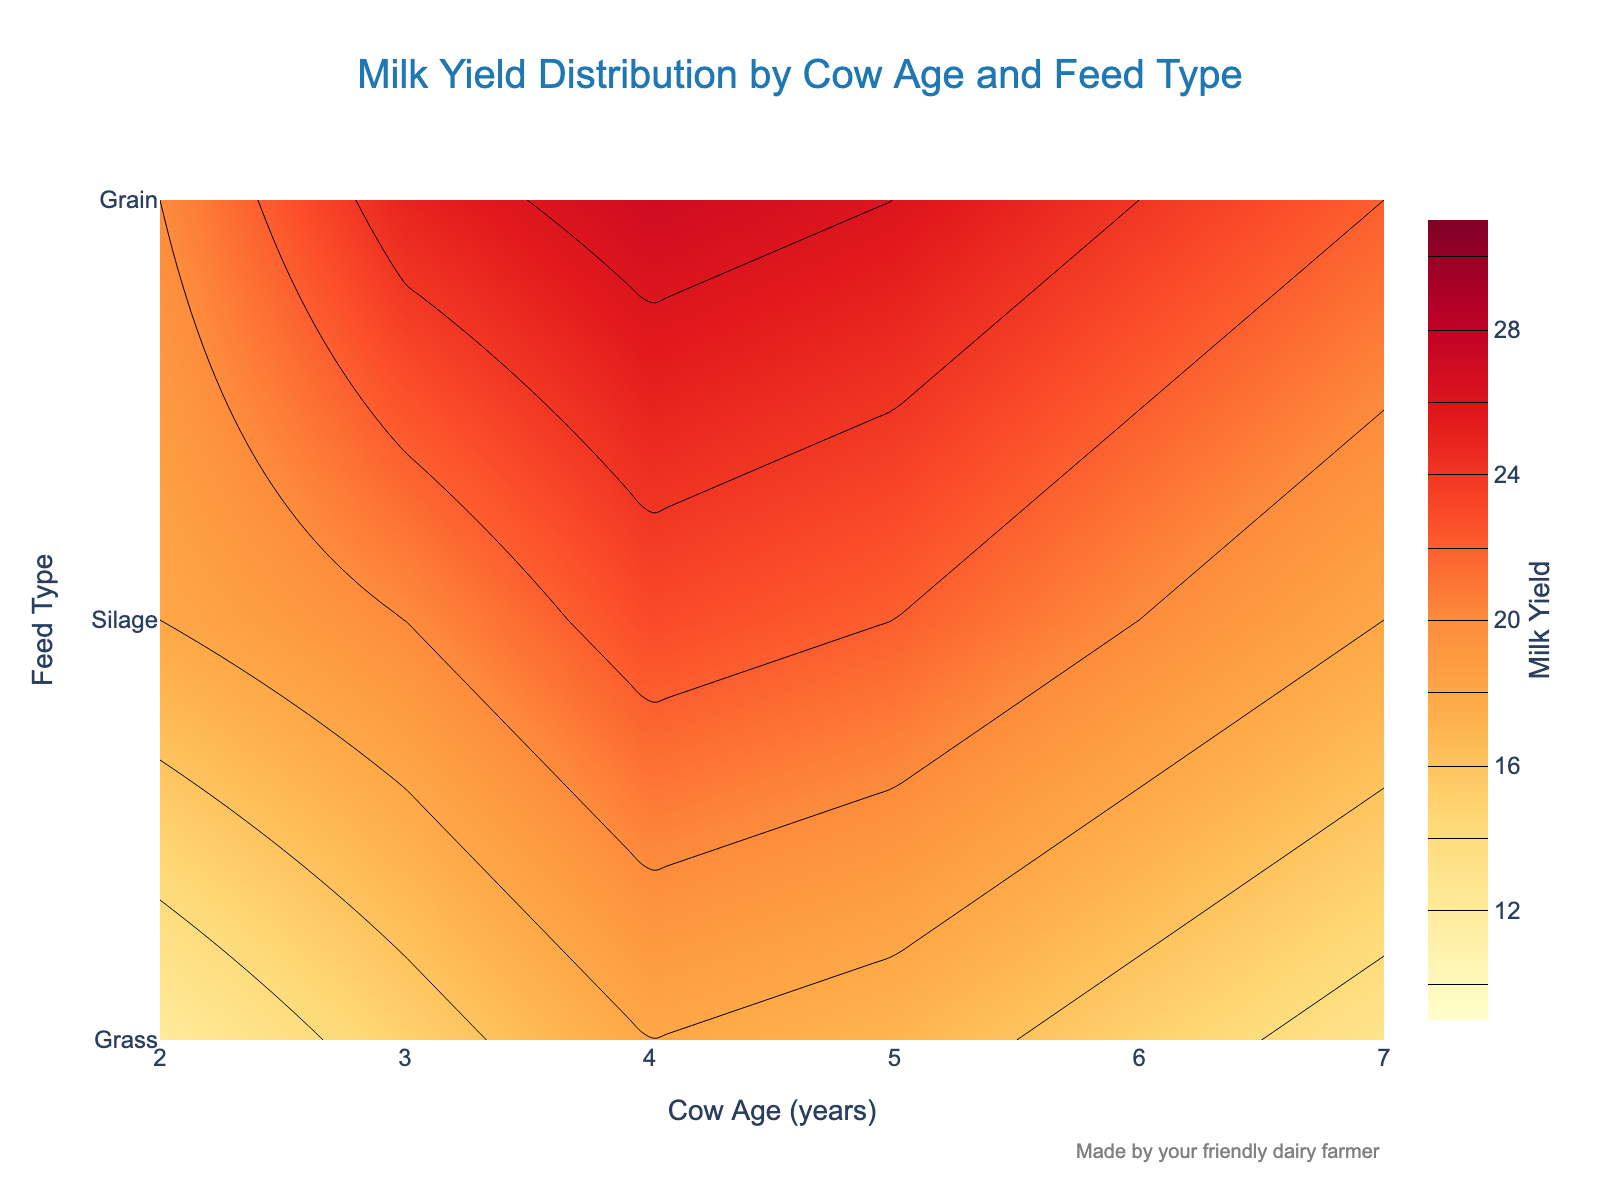what's the title of the figure? The title is usually found at the top of the figure. In this case, it says, "Milk Yield Distribution by Cow Age and Feed Type."
Answer: Milk Yield Distribution by Cow Age and Feed Type which feed type yields the highest milk production for 2-year-old cows? By looking at the contour lines for the age of 2 years, we see that Grain has the highest milk yield.
Answer: Grain at what cow age does the maximum yield from Silage occur? Trace the contour lines for the Silage feed type (usually marked on the y-axis). The highest yield for Silage occurs when the cow's age is 4 years.
Answer: 4 years how does milk yield from Grass change as cow age increases? Observe the countour lines for Grass. Milk yield from Grass initially increases until 4 years of age and then decreases as the cow gets older.
Answer: Increases until 4 years, then decreases what is the range of milk yield values represented in the figure? The color bar on the right side of the figure indicates the range of milk yield values. It starts at 10 and ends at 30.
Answer: 10 to 30 units compare the yield difference between Grass and Grain feed types for 5-year-old cows. For 5-year-old cows, the yield from Grass is 17, and from Grain is 26. The difference is 26 - 17 = 9.
Answer: 9 units what feed type is associated with the lowest yield overall? Look at the lowest bound of the contour lines for each feed type. Grass consistently shows the lowest overall milk yields.
Answer: Grass which cow age group shows the most variation in milk yield across different feed types? By observing the vertical spread of contour lines at different ages, we see that age 2 shows the most variation as the contour values change significantly between different feed types.
Answer: Age 2 is there a point where all feed types provide the same milk yield? Check if any contour lines for different feed types intersect at the same yield value. No such intersection is observed in the figure, indicating no point where all feed types yield the same.
Answer: No 